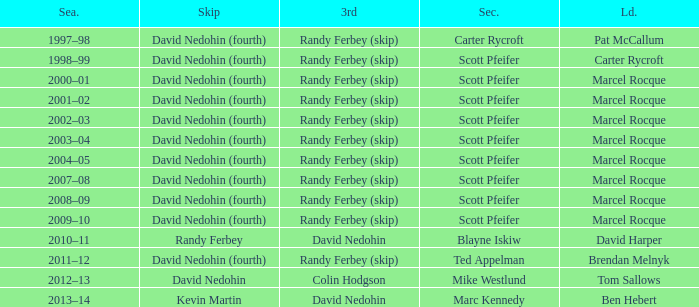Parse the full table. {'header': ['Sea.', 'Skip', '3rd', 'Sec.', 'Ld.'], 'rows': [['1997–98', 'David Nedohin (fourth)', 'Randy Ferbey (skip)', 'Carter Rycroft', 'Pat McCallum'], ['1998–99', 'David Nedohin (fourth)', 'Randy Ferbey (skip)', 'Scott Pfeifer', 'Carter Rycroft'], ['2000–01', 'David Nedohin (fourth)', 'Randy Ferbey (skip)', 'Scott Pfeifer', 'Marcel Rocque'], ['2001–02', 'David Nedohin (fourth)', 'Randy Ferbey (skip)', 'Scott Pfeifer', 'Marcel Rocque'], ['2002–03', 'David Nedohin (fourth)', 'Randy Ferbey (skip)', 'Scott Pfeifer', 'Marcel Rocque'], ['2003–04', 'David Nedohin (fourth)', 'Randy Ferbey (skip)', 'Scott Pfeifer', 'Marcel Rocque'], ['2004–05', 'David Nedohin (fourth)', 'Randy Ferbey (skip)', 'Scott Pfeifer', 'Marcel Rocque'], ['2007–08', 'David Nedohin (fourth)', 'Randy Ferbey (skip)', 'Scott Pfeifer', 'Marcel Rocque'], ['2008–09', 'David Nedohin (fourth)', 'Randy Ferbey (skip)', 'Scott Pfeifer', 'Marcel Rocque'], ['2009–10', 'David Nedohin (fourth)', 'Randy Ferbey (skip)', 'Scott Pfeifer', 'Marcel Rocque'], ['2010–11', 'Randy Ferbey', 'David Nedohin', 'Blayne Iskiw', 'David Harper'], ['2011–12', 'David Nedohin (fourth)', 'Randy Ferbey (skip)', 'Ted Appelman', 'Brendan Melnyk'], ['2012–13', 'David Nedohin', 'Colin Hodgson', 'Mike Westlund', 'Tom Sallows'], ['2013–14', 'Kevin Martin', 'David Nedohin', 'Marc Kennedy', 'Ben Hebert']]} Which Skip has a Season of 2002–03? David Nedohin (fourth). 